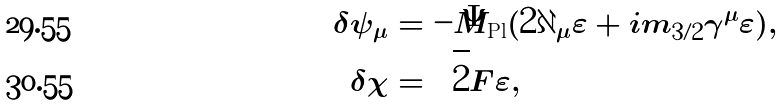Convert formula to latex. <formula><loc_0><loc_0><loc_500><loc_500>\delta \psi _ { \mu } & = - \bar { M } _ { \text {Pl} } ( 2 \partial _ { \mu } \varepsilon + i m _ { 3 / 2 } \gamma ^ { \mu } \varepsilon ) , \\ \delta \chi & = \sqrt { 2 } F \varepsilon ,</formula> 